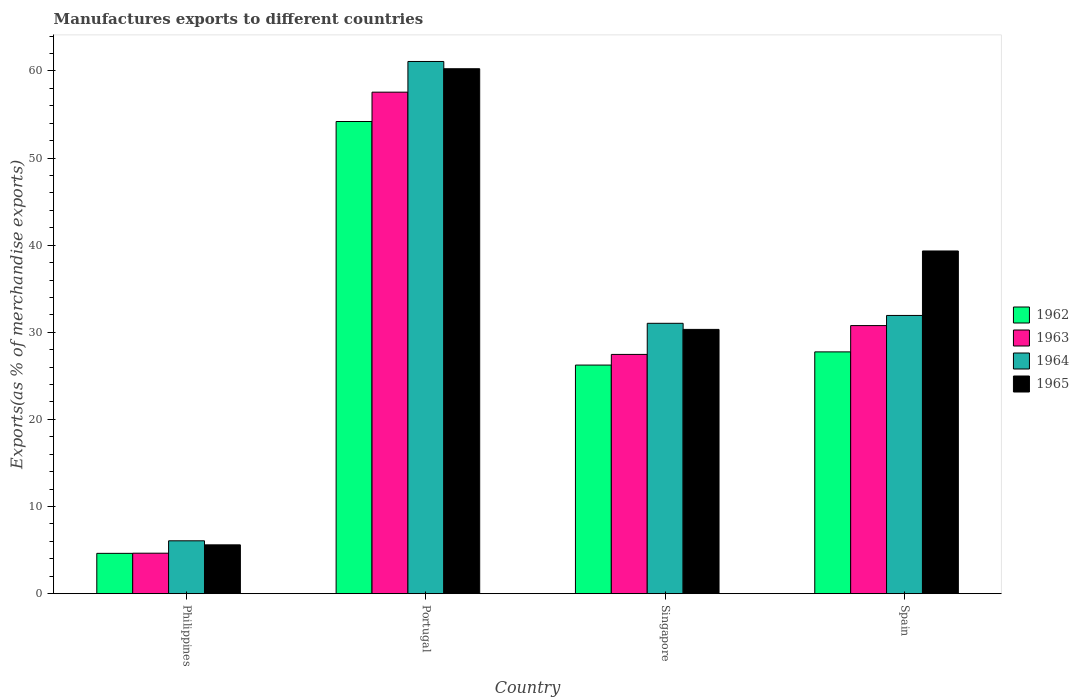How many groups of bars are there?
Offer a terse response. 4. Are the number of bars on each tick of the X-axis equal?
Provide a short and direct response. Yes. What is the label of the 3rd group of bars from the left?
Your answer should be very brief. Singapore. What is the percentage of exports to different countries in 1962 in Singapore?
Make the answer very short. 26.24. Across all countries, what is the maximum percentage of exports to different countries in 1962?
Your answer should be compact. 54.19. Across all countries, what is the minimum percentage of exports to different countries in 1965?
Ensure brevity in your answer.  5.6. What is the total percentage of exports to different countries in 1963 in the graph?
Offer a very short reply. 120.43. What is the difference between the percentage of exports to different countries in 1962 in Portugal and that in Spain?
Offer a very short reply. 26.44. What is the difference between the percentage of exports to different countries in 1962 in Philippines and the percentage of exports to different countries in 1964 in Portugal?
Your answer should be compact. -56.46. What is the average percentage of exports to different countries in 1962 per country?
Make the answer very short. 28.2. What is the difference between the percentage of exports to different countries of/in 1964 and percentage of exports to different countries of/in 1963 in Philippines?
Ensure brevity in your answer.  1.42. In how many countries, is the percentage of exports to different countries in 1963 greater than 10 %?
Provide a short and direct response. 3. What is the ratio of the percentage of exports to different countries in 1962 in Portugal to that in Spain?
Your response must be concise. 1.95. Is the percentage of exports to different countries in 1962 in Philippines less than that in Singapore?
Offer a terse response. Yes. What is the difference between the highest and the second highest percentage of exports to different countries in 1964?
Provide a succinct answer. -30.05. What is the difference between the highest and the lowest percentage of exports to different countries in 1963?
Make the answer very short. 52.92. What does the 1st bar from the left in Portugal represents?
Offer a very short reply. 1962. What does the 3rd bar from the right in Singapore represents?
Offer a very short reply. 1963. Is it the case that in every country, the sum of the percentage of exports to different countries in 1965 and percentage of exports to different countries in 1962 is greater than the percentage of exports to different countries in 1964?
Make the answer very short. Yes. How many bars are there?
Make the answer very short. 16. How many legend labels are there?
Your answer should be compact. 4. How are the legend labels stacked?
Give a very brief answer. Vertical. What is the title of the graph?
Give a very brief answer. Manufactures exports to different countries. What is the label or title of the X-axis?
Your answer should be compact. Country. What is the label or title of the Y-axis?
Give a very brief answer. Exports(as % of merchandise exports). What is the Exports(as % of merchandise exports) in 1962 in Philippines?
Offer a very short reply. 4.63. What is the Exports(as % of merchandise exports) of 1963 in Philippines?
Make the answer very short. 4.64. What is the Exports(as % of merchandise exports) in 1964 in Philippines?
Offer a terse response. 6.07. What is the Exports(as % of merchandise exports) in 1965 in Philippines?
Ensure brevity in your answer.  5.6. What is the Exports(as % of merchandise exports) in 1962 in Portugal?
Offer a very short reply. 54.19. What is the Exports(as % of merchandise exports) of 1963 in Portugal?
Your response must be concise. 57.56. What is the Exports(as % of merchandise exports) of 1964 in Portugal?
Make the answer very short. 61.08. What is the Exports(as % of merchandise exports) of 1965 in Portugal?
Offer a very short reply. 60.25. What is the Exports(as % of merchandise exports) of 1962 in Singapore?
Ensure brevity in your answer.  26.24. What is the Exports(as % of merchandise exports) of 1963 in Singapore?
Make the answer very short. 27.46. What is the Exports(as % of merchandise exports) in 1964 in Singapore?
Ensure brevity in your answer.  31.03. What is the Exports(as % of merchandise exports) in 1965 in Singapore?
Ensure brevity in your answer.  30.33. What is the Exports(as % of merchandise exports) in 1962 in Spain?
Give a very brief answer. 27.75. What is the Exports(as % of merchandise exports) of 1963 in Spain?
Provide a short and direct response. 30.77. What is the Exports(as % of merchandise exports) in 1964 in Spain?
Give a very brief answer. 31.93. What is the Exports(as % of merchandise exports) of 1965 in Spain?
Your response must be concise. 39.33. Across all countries, what is the maximum Exports(as % of merchandise exports) of 1962?
Offer a very short reply. 54.19. Across all countries, what is the maximum Exports(as % of merchandise exports) in 1963?
Offer a very short reply. 57.56. Across all countries, what is the maximum Exports(as % of merchandise exports) of 1964?
Provide a short and direct response. 61.08. Across all countries, what is the maximum Exports(as % of merchandise exports) of 1965?
Keep it short and to the point. 60.25. Across all countries, what is the minimum Exports(as % of merchandise exports) of 1962?
Keep it short and to the point. 4.63. Across all countries, what is the minimum Exports(as % of merchandise exports) of 1963?
Keep it short and to the point. 4.64. Across all countries, what is the minimum Exports(as % of merchandise exports) in 1964?
Give a very brief answer. 6.07. Across all countries, what is the minimum Exports(as % of merchandise exports) of 1965?
Your response must be concise. 5.6. What is the total Exports(as % of merchandise exports) of 1962 in the graph?
Your answer should be very brief. 112.81. What is the total Exports(as % of merchandise exports) of 1963 in the graph?
Offer a very short reply. 120.43. What is the total Exports(as % of merchandise exports) of 1964 in the graph?
Ensure brevity in your answer.  130.11. What is the total Exports(as % of merchandise exports) in 1965 in the graph?
Give a very brief answer. 135.52. What is the difference between the Exports(as % of merchandise exports) of 1962 in Philippines and that in Portugal?
Give a very brief answer. -49.57. What is the difference between the Exports(as % of merchandise exports) in 1963 in Philippines and that in Portugal?
Give a very brief answer. -52.92. What is the difference between the Exports(as % of merchandise exports) of 1964 in Philippines and that in Portugal?
Make the answer very short. -55.02. What is the difference between the Exports(as % of merchandise exports) in 1965 in Philippines and that in Portugal?
Offer a very short reply. -54.65. What is the difference between the Exports(as % of merchandise exports) in 1962 in Philippines and that in Singapore?
Your answer should be very brief. -21.61. What is the difference between the Exports(as % of merchandise exports) of 1963 in Philippines and that in Singapore?
Keep it short and to the point. -22.82. What is the difference between the Exports(as % of merchandise exports) of 1964 in Philippines and that in Singapore?
Make the answer very short. -24.96. What is the difference between the Exports(as % of merchandise exports) in 1965 in Philippines and that in Singapore?
Offer a very short reply. -24.73. What is the difference between the Exports(as % of merchandise exports) in 1962 in Philippines and that in Spain?
Offer a terse response. -23.12. What is the difference between the Exports(as % of merchandise exports) in 1963 in Philippines and that in Spain?
Provide a short and direct response. -26.13. What is the difference between the Exports(as % of merchandise exports) in 1964 in Philippines and that in Spain?
Your response must be concise. -25.87. What is the difference between the Exports(as % of merchandise exports) in 1965 in Philippines and that in Spain?
Provide a short and direct response. -33.73. What is the difference between the Exports(as % of merchandise exports) of 1962 in Portugal and that in Singapore?
Ensure brevity in your answer.  27.96. What is the difference between the Exports(as % of merchandise exports) of 1963 in Portugal and that in Singapore?
Provide a succinct answer. 30.1. What is the difference between the Exports(as % of merchandise exports) in 1964 in Portugal and that in Singapore?
Provide a succinct answer. 30.05. What is the difference between the Exports(as % of merchandise exports) in 1965 in Portugal and that in Singapore?
Offer a very short reply. 29.92. What is the difference between the Exports(as % of merchandise exports) in 1962 in Portugal and that in Spain?
Your answer should be compact. 26.44. What is the difference between the Exports(as % of merchandise exports) of 1963 in Portugal and that in Spain?
Provide a short and direct response. 26.79. What is the difference between the Exports(as % of merchandise exports) of 1964 in Portugal and that in Spain?
Offer a very short reply. 29.15. What is the difference between the Exports(as % of merchandise exports) in 1965 in Portugal and that in Spain?
Your response must be concise. 20.92. What is the difference between the Exports(as % of merchandise exports) of 1962 in Singapore and that in Spain?
Offer a very short reply. -1.51. What is the difference between the Exports(as % of merchandise exports) of 1963 in Singapore and that in Spain?
Keep it short and to the point. -3.31. What is the difference between the Exports(as % of merchandise exports) of 1964 in Singapore and that in Spain?
Give a very brief answer. -0.9. What is the difference between the Exports(as % of merchandise exports) of 1965 in Singapore and that in Spain?
Make the answer very short. -9. What is the difference between the Exports(as % of merchandise exports) of 1962 in Philippines and the Exports(as % of merchandise exports) of 1963 in Portugal?
Offer a very short reply. -52.93. What is the difference between the Exports(as % of merchandise exports) in 1962 in Philippines and the Exports(as % of merchandise exports) in 1964 in Portugal?
Your answer should be very brief. -56.46. What is the difference between the Exports(as % of merchandise exports) in 1962 in Philippines and the Exports(as % of merchandise exports) in 1965 in Portugal?
Ensure brevity in your answer.  -55.62. What is the difference between the Exports(as % of merchandise exports) of 1963 in Philippines and the Exports(as % of merchandise exports) of 1964 in Portugal?
Make the answer very short. -56.44. What is the difference between the Exports(as % of merchandise exports) in 1963 in Philippines and the Exports(as % of merchandise exports) in 1965 in Portugal?
Offer a very short reply. -55.61. What is the difference between the Exports(as % of merchandise exports) in 1964 in Philippines and the Exports(as % of merchandise exports) in 1965 in Portugal?
Your answer should be very brief. -54.18. What is the difference between the Exports(as % of merchandise exports) of 1962 in Philippines and the Exports(as % of merchandise exports) of 1963 in Singapore?
Give a very brief answer. -22.83. What is the difference between the Exports(as % of merchandise exports) of 1962 in Philippines and the Exports(as % of merchandise exports) of 1964 in Singapore?
Offer a terse response. -26.4. What is the difference between the Exports(as % of merchandise exports) of 1962 in Philippines and the Exports(as % of merchandise exports) of 1965 in Singapore?
Your response must be concise. -25.7. What is the difference between the Exports(as % of merchandise exports) of 1963 in Philippines and the Exports(as % of merchandise exports) of 1964 in Singapore?
Provide a short and direct response. -26.39. What is the difference between the Exports(as % of merchandise exports) of 1963 in Philippines and the Exports(as % of merchandise exports) of 1965 in Singapore?
Your response must be concise. -25.69. What is the difference between the Exports(as % of merchandise exports) of 1964 in Philippines and the Exports(as % of merchandise exports) of 1965 in Singapore?
Offer a terse response. -24.27. What is the difference between the Exports(as % of merchandise exports) of 1962 in Philippines and the Exports(as % of merchandise exports) of 1963 in Spain?
Offer a terse response. -26.14. What is the difference between the Exports(as % of merchandise exports) in 1962 in Philippines and the Exports(as % of merchandise exports) in 1964 in Spain?
Provide a short and direct response. -27.31. What is the difference between the Exports(as % of merchandise exports) of 1962 in Philippines and the Exports(as % of merchandise exports) of 1965 in Spain?
Your response must be concise. -34.71. What is the difference between the Exports(as % of merchandise exports) of 1963 in Philippines and the Exports(as % of merchandise exports) of 1964 in Spain?
Give a very brief answer. -27.29. What is the difference between the Exports(as % of merchandise exports) in 1963 in Philippines and the Exports(as % of merchandise exports) in 1965 in Spain?
Provide a succinct answer. -34.69. What is the difference between the Exports(as % of merchandise exports) of 1964 in Philippines and the Exports(as % of merchandise exports) of 1965 in Spain?
Your answer should be compact. -33.27. What is the difference between the Exports(as % of merchandise exports) of 1962 in Portugal and the Exports(as % of merchandise exports) of 1963 in Singapore?
Your answer should be very brief. 26.73. What is the difference between the Exports(as % of merchandise exports) in 1962 in Portugal and the Exports(as % of merchandise exports) in 1964 in Singapore?
Provide a succinct answer. 23.16. What is the difference between the Exports(as % of merchandise exports) of 1962 in Portugal and the Exports(as % of merchandise exports) of 1965 in Singapore?
Make the answer very short. 23.86. What is the difference between the Exports(as % of merchandise exports) in 1963 in Portugal and the Exports(as % of merchandise exports) in 1964 in Singapore?
Your response must be concise. 26.53. What is the difference between the Exports(as % of merchandise exports) of 1963 in Portugal and the Exports(as % of merchandise exports) of 1965 in Singapore?
Provide a succinct answer. 27.23. What is the difference between the Exports(as % of merchandise exports) of 1964 in Portugal and the Exports(as % of merchandise exports) of 1965 in Singapore?
Make the answer very short. 30.75. What is the difference between the Exports(as % of merchandise exports) in 1962 in Portugal and the Exports(as % of merchandise exports) in 1963 in Spain?
Your answer should be compact. 23.42. What is the difference between the Exports(as % of merchandise exports) of 1962 in Portugal and the Exports(as % of merchandise exports) of 1964 in Spain?
Give a very brief answer. 22.26. What is the difference between the Exports(as % of merchandise exports) of 1962 in Portugal and the Exports(as % of merchandise exports) of 1965 in Spain?
Your answer should be compact. 14.86. What is the difference between the Exports(as % of merchandise exports) of 1963 in Portugal and the Exports(as % of merchandise exports) of 1964 in Spain?
Your answer should be compact. 25.63. What is the difference between the Exports(as % of merchandise exports) in 1963 in Portugal and the Exports(as % of merchandise exports) in 1965 in Spain?
Provide a short and direct response. 18.23. What is the difference between the Exports(as % of merchandise exports) in 1964 in Portugal and the Exports(as % of merchandise exports) in 1965 in Spain?
Ensure brevity in your answer.  21.75. What is the difference between the Exports(as % of merchandise exports) in 1962 in Singapore and the Exports(as % of merchandise exports) in 1963 in Spain?
Your answer should be very brief. -4.53. What is the difference between the Exports(as % of merchandise exports) of 1962 in Singapore and the Exports(as % of merchandise exports) of 1964 in Spain?
Your answer should be compact. -5.7. What is the difference between the Exports(as % of merchandise exports) in 1962 in Singapore and the Exports(as % of merchandise exports) in 1965 in Spain?
Your answer should be very brief. -13.1. What is the difference between the Exports(as % of merchandise exports) in 1963 in Singapore and the Exports(as % of merchandise exports) in 1964 in Spain?
Your answer should be compact. -4.47. What is the difference between the Exports(as % of merchandise exports) in 1963 in Singapore and the Exports(as % of merchandise exports) in 1965 in Spain?
Offer a terse response. -11.87. What is the difference between the Exports(as % of merchandise exports) of 1964 in Singapore and the Exports(as % of merchandise exports) of 1965 in Spain?
Keep it short and to the point. -8.3. What is the average Exports(as % of merchandise exports) of 1962 per country?
Your answer should be compact. 28.2. What is the average Exports(as % of merchandise exports) in 1963 per country?
Provide a succinct answer. 30.11. What is the average Exports(as % of merchandise exports) in 1964 per country?
Give a very brief answer. 32.53. What is the average Exports(as % of merchandise exports) of 1965 per country?
Offer a terse response. 33.88. What is the difference between the Exports(as % of merchandise exports) of 1962 and Exports(as % of merchandise exports) of 1963 in Philippines?
Ensure brevity in your answer.  -0.02. What is the difference between the Exports(as % of merchandise exports) of 1962 and Exports(as % of merchandise exports) of 1964 in Philippines?
Your answer should be compact. -1.44. What is the difference between the Exports(as % of merchandise exports) of 1962 and Exports(as % of merchandise exports) of 1965 in Philippines?
Keep it short and to the point. -0.98. What is the difference between the Exports(as % of merchandise exports) of 1963 and Exports(as % of merchandise exports) of 1964 in Philippines?
Provide a succinct answer. -1.42. What is the difference between the Exports(as % of merchandise exports) in 1963 and Exports(as % of merchandise exports) in 1965 in Philippines?
Offer a very short reply. -0.96. What is the difference between the Exports(as % of merchandise exports) of 1964 and Exports(as % of merchandise exports) of 1965 in Philippines?
Make the answer very short. 0.46. What is the difference between the Exports(as % of merchandise exports) in 1962 and Exports(as % of merchandise exports) in 1963 in Portugal?
Offer a very short reply. -3.37. What is the difference between the Exports(as % of merchandise exports) of 1962 and Exports(as % of merchandise exports) of 1964 in Portugal?
Your response must be concise. -6.89. What is the difference between the Exports(as % of merchandise exports) of 1962 and Exports(as % of merchandise exports) of 1965 in Portugal?
Ensure brevity in your answer.  -6.06. What is the difference between the Exports(as % of merchandise exports) of 1963 and Exports(as % of merchandise exports) of 1964 in Portugal?
Keep it short and to the point. -3.52. What is the difference between the Exports(as % of merchandise exports) of 1963 and Exports(as % of merchandise exports) of 1965 in Portugal?
Provide a short and direct response. -2.69. What is the difference between the Exports(as % of merchandise exports) of 1964 and Exports(as % of merchandise exports) of 1965 in Portugal?
Offer a very short reply. 0.83. What is the difference between the Exports(as % of merchandise exports) in 1962 and Exports(as % of merchandise exports) in 1963 in Singapore?
Provide a short and direct response. -1.22. What is the difference between the Exports(as % of merchandise exports) of 1962 and Exports(as % of merchandise exports) of 1964 in Singapore?
Your answer should be very brief. -4.79. What is the difference between the Exports(as % of merchandise exports) in 1962 and Exports(as % of merchandise exports) in 1965 in Singapore?
Your response must be concise. -4.1. What is the difference between the Exports(as % of merchandise exports) in 1963 and Exports(as % of merchandise exports) in 1964 in Singapore?
Provide a short and direct response. -3.57. What is the difference between the Exports(as % of merchandise exports) of 1963 and Exports(as % of merchandise exports) of 1965 in Singapore?
Your answer should be compact. -2.87. What is the difference between the Exports(as % of merchandise exports) of 1964 and Exports(as % of merchandise exports) of 1965 in Singapore?
Your answer should be compact. 0.7. What is the difference between the Exports(as % of merchandise exports) in 1962 and Exports(as % of merchandise exports) in 1963 in Spain?
Offer a terse response. -3.02. What is the difference between the Exports(as % of merchandise exports) in 1962 and Exports(as % of merchandise exports) in 1964 in Spain?
Ensure brevity in your answer.  -4.18. What is the difference between the Exports(as % of merchandise exports) of 1962 and Exports(as % of merchandise exports) of 1965 in Spain?
Your response must be concise. -11.58. What is the difference between the Exports(as % of merchandise exports) in 1963 and Exports(as % of merchandise exports) in 1964 in Spain?
Your answer should be compact. -1.16. What is the difference between the Exports(as % of merchandise exports) in 1963 and Exports(as % of merchandise exports) in 1965 in Spain?
Give a very brief answer. -8.56. What is the difference between the Exports(as % of merchandise exports) of 1964 and Exports(as % of merchandise exports) of 1965 in Spain?
Your answer should be very brief. -7.4. What is the ratio of the Exports(as % of merchandise exports) in 1962 in Philippines to that in Portugal?
Ensure brevity in your answer.  0.09. What is the ratio of the Exports(as % of merchandise exports) in 1963 in Philippines to that in Portugal?
Offer a terse response. 0.08. What is the ratio of the Exports(as % of merchandise exports) of 1964 in Philippines to that in Portugal?
Keep it short and to the point. 0.1. What is the ratio of the Exports(as % of merchandise exports) in 1965 in Philippines to that in Portugal?
Offer a terse response. 0.09. What is the ratio of the Exports(as % of merchandise exports) in 1962 in Philippines to that in Singapore?
Provide a short and direct response. 0.18. What is the ratio of the Exports(as % of merchandise exports) in 1963 in Philippines to that in Singapore?
Offer a terse response. 0.17. What is the ratio of the Exports(as % of merchandise exports) in 1964 in Philippines to that in Singapore?
Your response must be concise. 0.2. What is the ratio of the Exports(as % of merchandise exports) in 1965 in Philippines to that in Singapore?
Provide a short and direct response. 0.18. What is the ratio of the Exports(as % of merchandise exports) in 1962 in Philippines to that in Spain?
Your answer should be very brief. 0.17. What is the ratio of the Exports(as % of merchandise exports) in 1963 in Philippines to that in Spain?
Keep it short and to the point. 0.15. What is the ratio of the Exports(as % of merchandise exports) of 1964 in Philippines to that in Spain?
Your answer should be very brief. 0.19. What is the ratio of the Exports(as % of merchandise exports) of 1965 in Philippines to that in Spain?
Provide a succinct answer. 0.14. What is the ratio of the Exports(as % of merchandise exports) in 1962 in Portugal to that in Singapore?
Offer a terse response. 2.07. What is the ratio of the Exports(as % of merchandise exports) in 1963 in Portugal to that in Singapore?
Keep it short and to the point. 2.1. What is the ratio of the Exports(as % of merchandise exports) of 1964 in Portugal to that in Singapore?
Offer a terse response. 1.97. What is the ratio of the Exports(as % of merchandise exports) of 1965 in Portugal to that in Singapore?
Your answer should be very brief. 1.99. What is the ratio of the Exports(as % of merchandise exports) of 1962 in Portugal to that in Spain?
Keep it short and to the point. 1.95. What is the ratio of the Exports(as % of merchandise exports) of 1963 in Portugal to that in Spain?
Provide a short and direct response. 1.87. What is the ratio of the Exports(as % of merchandise exports) in 1964 in Portugal to that in Spain?
Your answer should be compact. 1.91. What is the ratio of the Exports(as % of merchandise exports) in 1965 in Portugal to that in Spain?
Give a very brief answer. 1.53. What is the ratio of the Exports(as % of merchandise exports) in 1962 in Singapore to that in Spain?
Your answer should be compact. 0.95. What is the ratio of the Exports(as % of merchandise exports) of 1963 in Singapore to that in Spain?
Keep it short and to the point. 0.89. What is the ratio of the Exports(as % of merchandise exports) in 1964 in Singapore to that in Spain?
Offer a very short reply. 0.97. What is the ratio of the Exports(as % of merchandise exports) of 1965 in Singapore to that in Spain?
Offer a very short reply. 0.77. What is the difference between the highest and the second highest Exports(as % of merchandise exports) in 1962?
Provide a succinct answer. 26.44. What is the difference between the highest and the second highest Exports(as % of merchandise exports) of 1963?
Offer a very short reply. 26.79. What is the difference between the highest and the second highest Exports(as % of merchandise exports) in 1964?
Provide a short and direct response. 29.15. What is the difference between the highest and the second highest Exports(as % of merchandise exports) of 1965?
Ensure brevity in your answer.  20.92. What is the difference between the highest and the lowest Exports(as % of merchandise exports) in 1962?
Make the answer very short. 49.57. What is the difference between the highest and the lowest Exports(as % of merchandise exports) of 1963?
Offer a very short reply. 52.92. What is the difference between the highest and the lowest Exports(as % of merchandise exports) of 1964?
Give a very brief answer. 55.02. What is the difference between the highest and the lowest Exports(as % of merchandise exports) of 1965?
Offer a terse response. 54.65. 